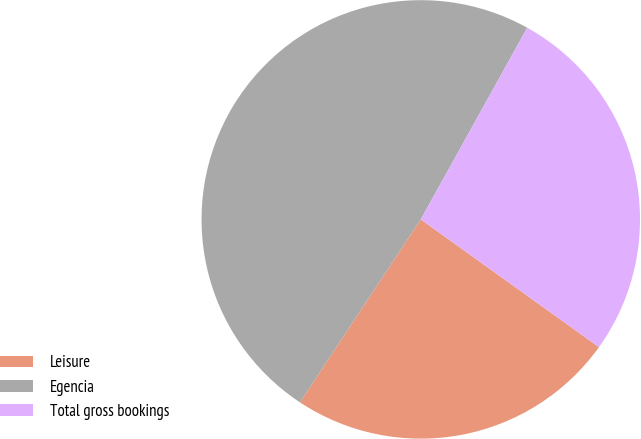Convert chart to OTSL. <chart><loc_0><loc_0><loc_500><loc_500><pie_chart><fcel>Leisure<fcel>Egencia<fcel>Total gross bookings<nl><fcel>24.39%<fcel>48.78%<fcel>26.83%<nl></chart> 